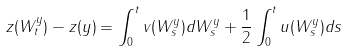Convert formula to latex. <formula><loc_0><loc_0><loc_500><loc_500>z ( W ^ { y } _ { t } ) - z ( y ) = \int _ { 0 } ^ { t } v ( W ^ { y } _ { s } ) d W ^ { y } _ { s } + \frac { 1 } { 2 } \int _ { 0 } ^ { t } u ( W ^ { y } _ { s } ) d s</formula> 